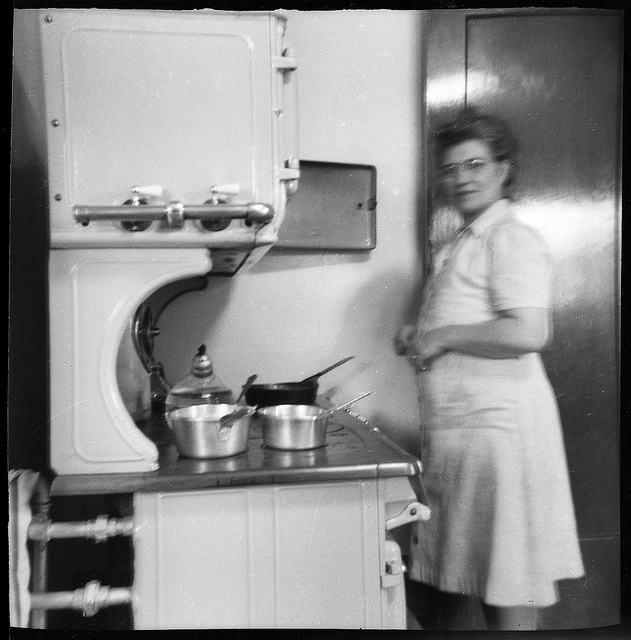Describe the objects in this image and their specific colors. I can see people in black, lightgray, darkgray, and gray tones, spoon in black, gray, darkgray, and lightgray tones, spoon in black, gray, darkgray, and lightgray tones, and spoon in darkgray, lightgray, gray, and black tones in this image. 